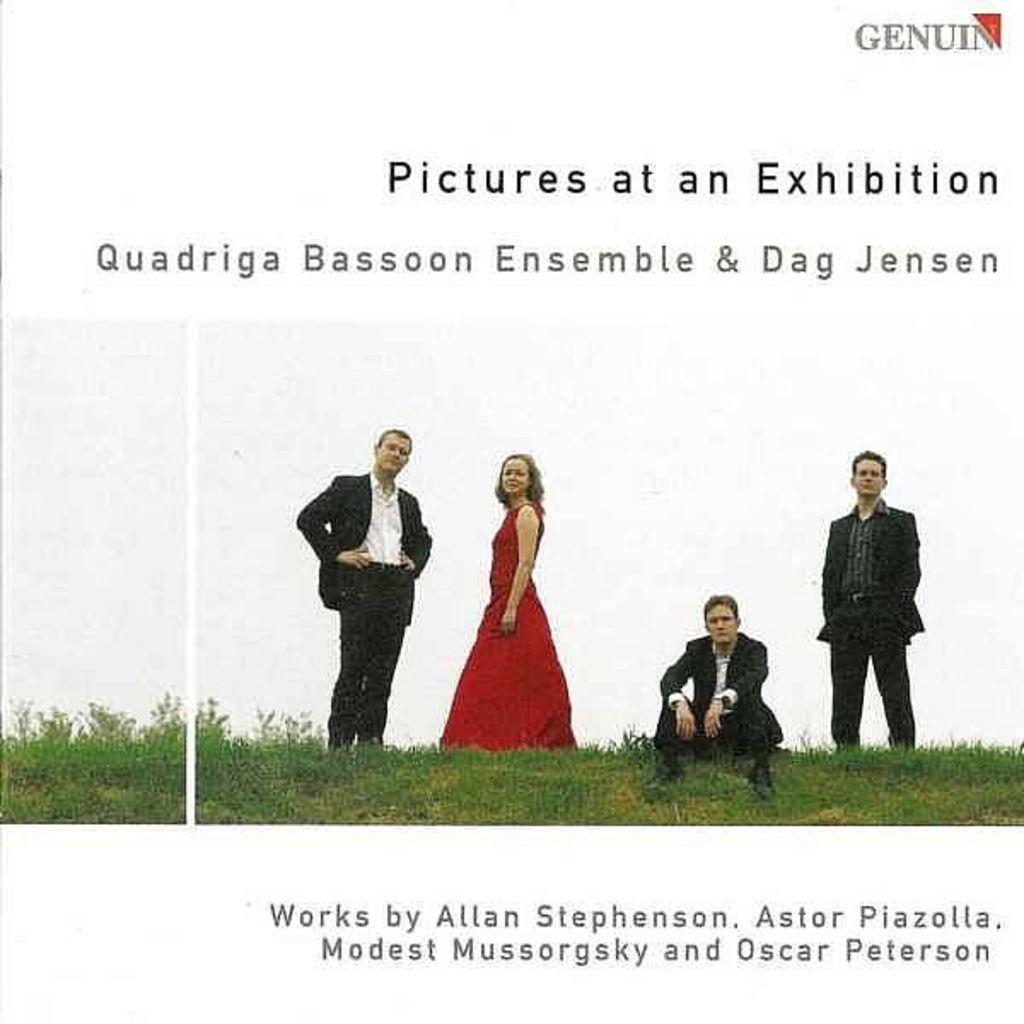Could you give a brief overview of what you see in this image? This might be a poster, in this image in the center there are four people three of them are standing and one person is sitting and there is a grass. And at the top and bottom of the image there is text. 